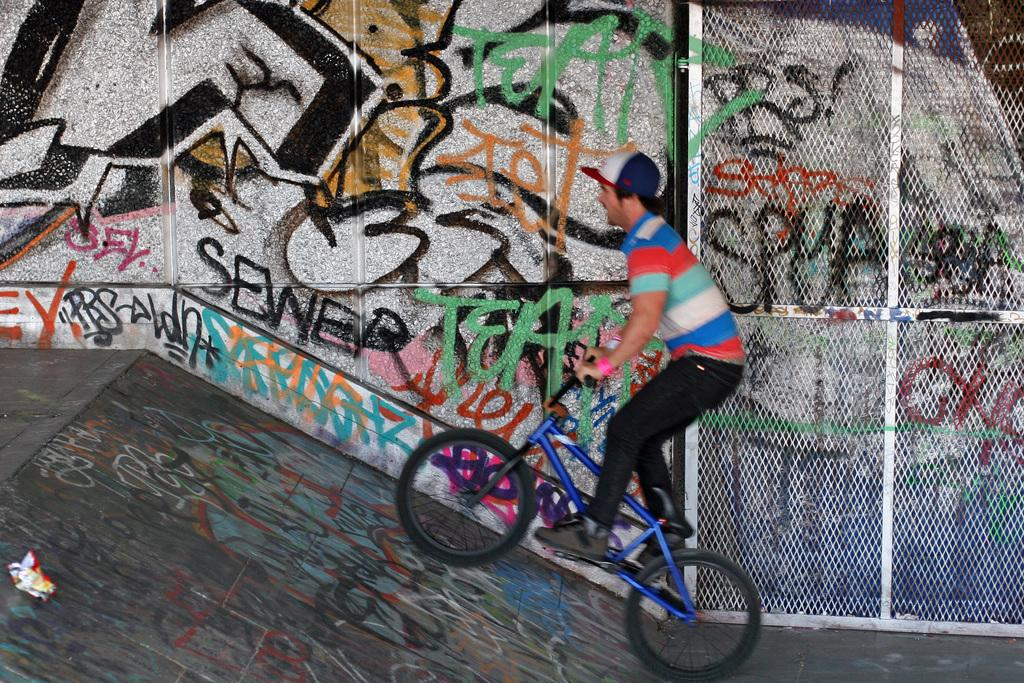What is the main subject of the image? There is a man in the image. What is the man doing in the image? The man is riding a bicycle. What type of headwear is the man wearing? The man is wearing a cap. What can be seen in the background of the image? There is a wall in the background of the image. Can you see a rabbit using a rake in the image? No, there is no rabbit or rake present in the image. What type of wheel is attached to the bicycle in the image? The image does not show the specific type of wheel on the bicycle, only that the man is riding a bicycle. 